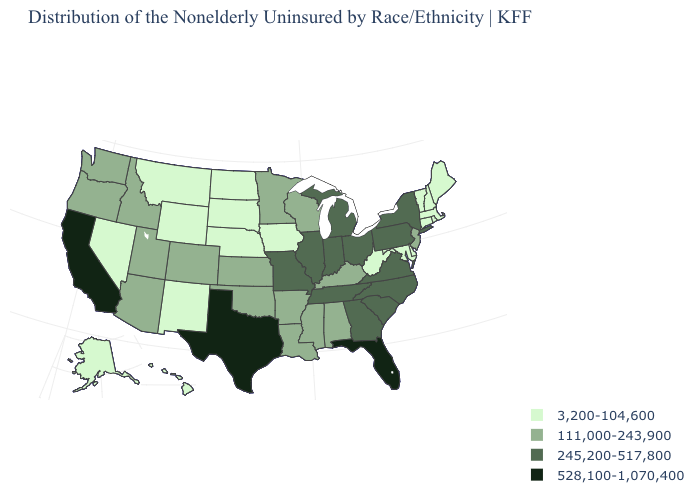Among the states that border Georgia , which have the lowest value?
Quick response, please. Alabama. What is the value of Arizona?
Answer briefly. 111,000-243,900. Which states have the lowest value in the USA?
Give a very brief answer. Alaska, Connecticut, Delaware, Hawaii, Iowa, Maine, Maryland, Massachusetts, Montana, Nebraska, Nevada, New Hampshire, New Mexico, North Dakota, Rhode Island, South Dakota, Vermont, West Virginia, Wyoming. Name the states that have a value in the range 245,200-517,800?
Answer briefly. Georgia, Illinois, Indiana, Michigan, Missouri, New York, North Carolina, Ohio, Pennsylvania, South Carolina, Tennessee, Virginia. What is the value of Hawaii?
Short answer required. 3,200-104,600. What is the lowest value in the USA?
Write a very short answer. 3,200-104,600. Among the states that border Virginia , which have the lowest value?
Give a very brief answer. Maryland, West Virginia. Name the states that have a value in the range 245,200-517,800?
Keep it brief. Georgia, Illinois, Indiana, Michigan, Missouri, New York, North Carolina, Ohio, Pennsylvania, South Carolina, Tennessee, Virginia. Does Indiana have the highest value in the MidWest?
Be succinct. Yes. Name the states that have a value in the range 111,000-243,900?
Be succinct. Alabama, Arizona, Arkansas, Colorado, Idaho, Kansas, Kentucky, Louisiana, Minnesota, Mississippi, New Jersey, Oklahoma, Oregon, Utah, Washington, Wisconsin. What is the value of Washington?
Answer briefly. 111,000-243,900. Does Minnesota have the same value as Wisconsin?
Keep it brief. Yes. Name the states that have a value in the range 245,200-517,800?
Short answer required. Georgia, Illinois, Indiana, Michigan, Missouri, New York, North Carolina, Ohio, Pennsylvania, South Carolina, Tennessee, Virginia. What is the value of Alabama?
Short answer required. 111,000-243,900. What is the lowest value in the USA?
Write a very short answer. 3,200-104,600. 